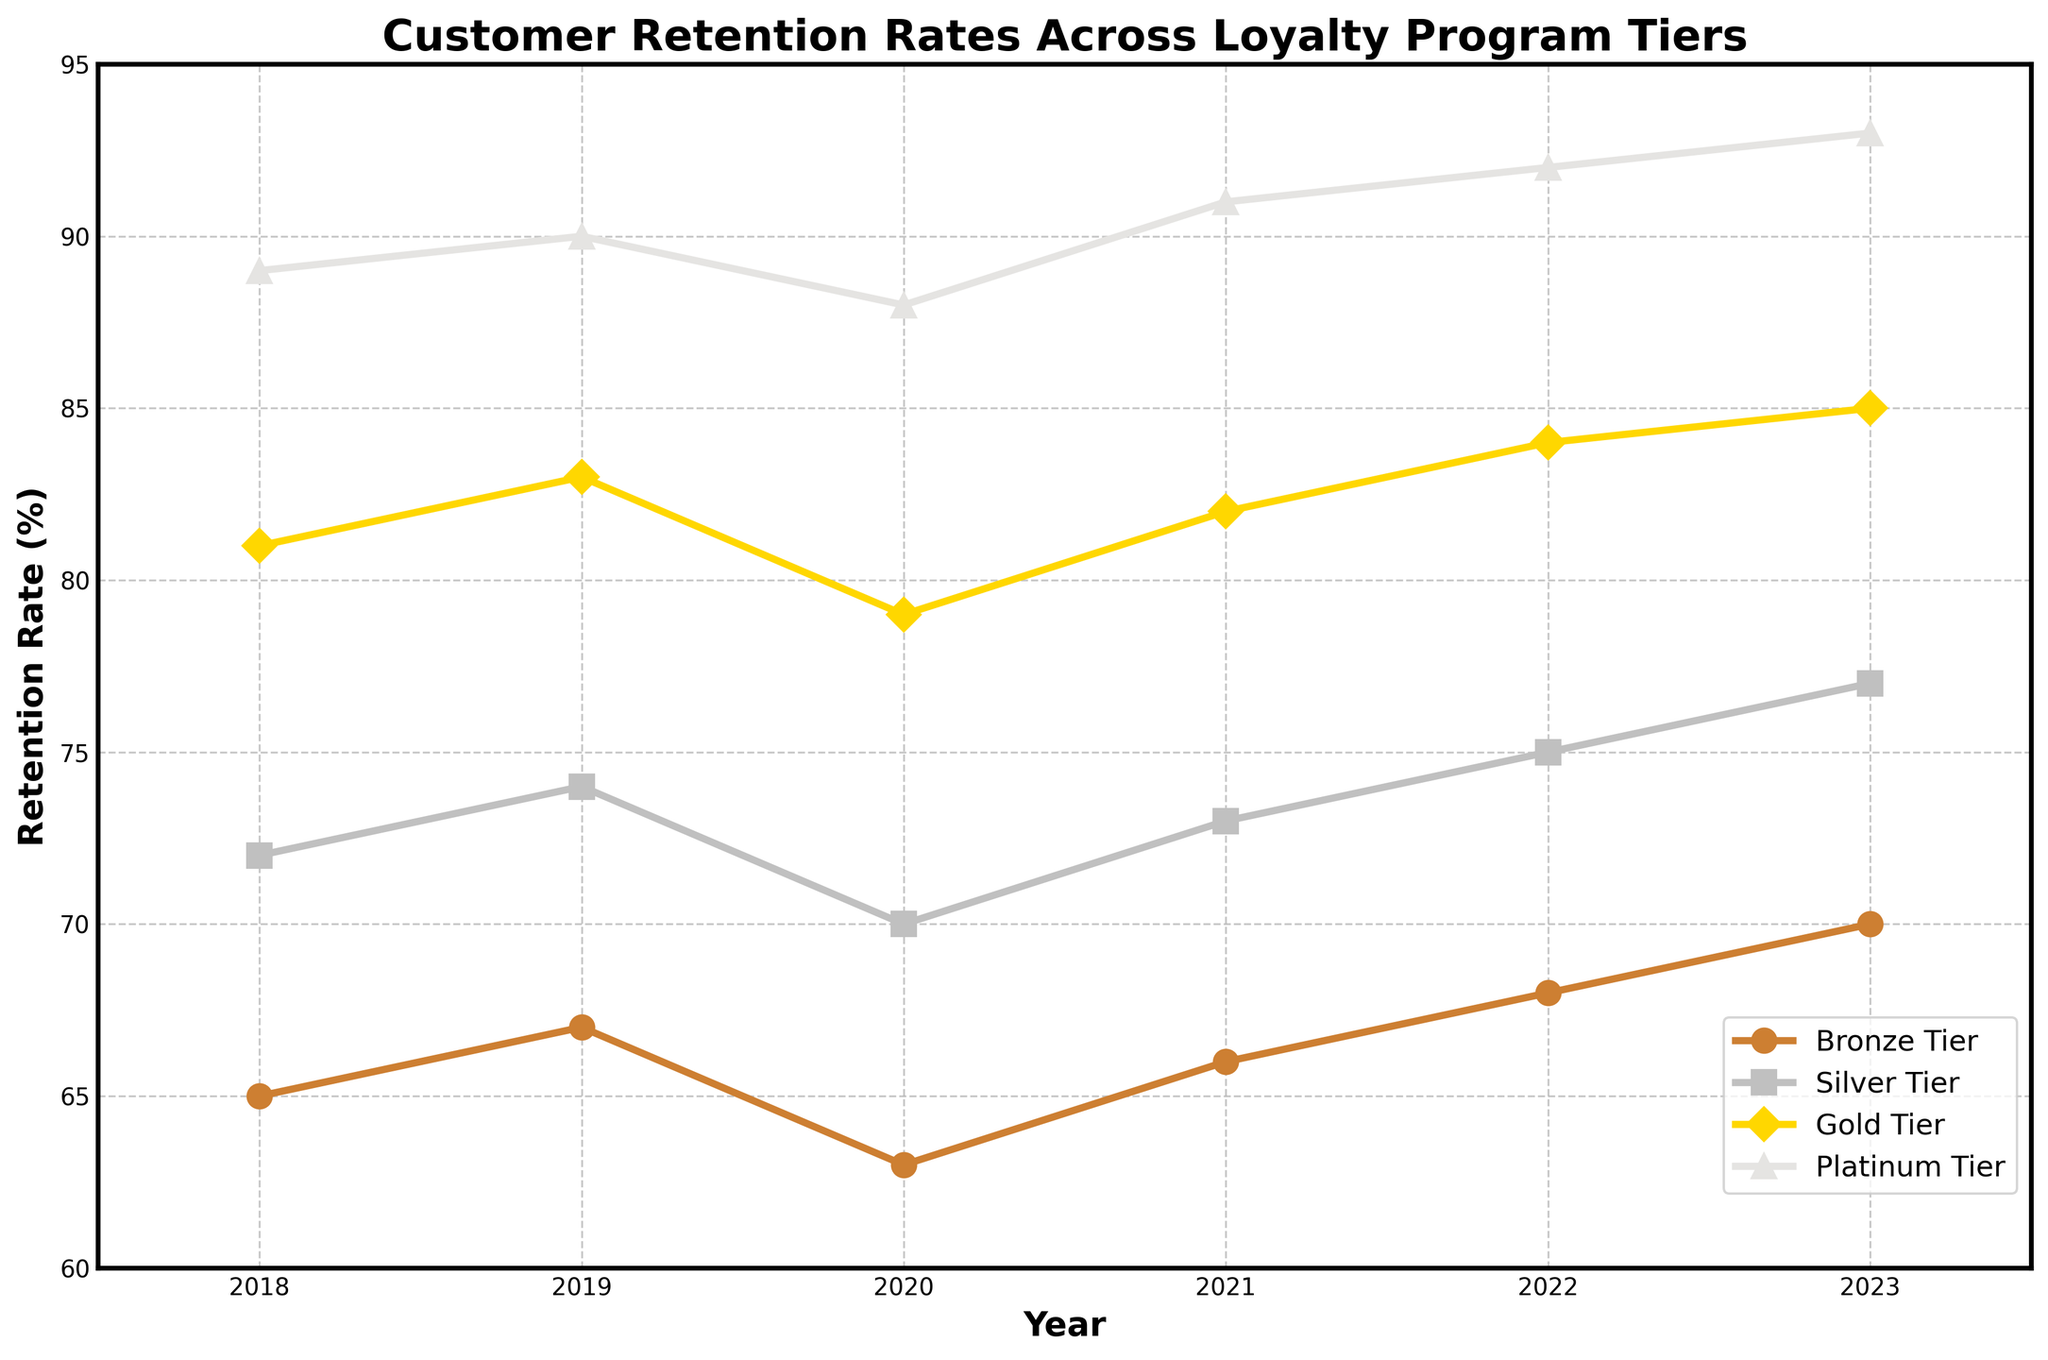Which year did the Bronze Tier have the lowest retention rate? Observing the line corresponding to the Bronze Tier, we notice that the lowest point is in the year 2020 at 63%.
Answer: 2020 Between 2018 and 2023, which tier had the highest overall retention rate? By looking at the highest points along each line from 2018 to 2023, the Platinum Tier in 2023 reached the highest level at 93%.
Answer: Platinum Tier By how much did the retention rate for the Gold Tier change from 2018 to 2023? We identify the retention rate for the Gold Tier in 2018 as 81% and in 2023 as 85%. The change is 85% - 81% = 4%.
Answer: 4% If we average the retention rates in 2021 across all tiers, what is the result? Adding the rates for each tier in 2021: 66% (Bronze) + 73% (Silver) + 82% (Gold) + 91% (Platinum) = 312%. Then, divide by 4: 312%/4 = 78%.
Answer: 78% Do the Silver and Gold tiers ever have the same retention rate within the displayed years? By examining each year along the chart, it is clear that the Silver and Gold tiers never intersect or share the same retention rate at any point.
Answer: No Which tier demonstrated the most consistent retention rate from 2018 to 2023? The most consistent retention rate would show the least variability. Observing the figures, the Silver Tier consistently stays around the 72-75% range, making it the most stable.
Answer: Silver Tier In which year did the Platinum Tier surpass a retention rate of 90%? Looking at the Platinum Tier line, it first surpasses 90% in the year 2019, reaching 91% by 2021 and continuing to grow.
Answer: 2019 Compare the increase in retention rate for the Silver Tier from 2018 to 2023 with that of the Bronze Tier. For the Silver Tier, the rate increased from 72% to 77%, a change of 5%. For the Bronze Tier, it increased from 65% to 70%, also a change of 5%. Both increased by the same amount.
Answer: 5% What is the average retention rate for the Platinum Tier across all displayed years? Sum the values across the years: 89% + 90% + 88% + 91% + 92% + 93% = 543%. Then, divide by 6: 543%/6 = 90.5%.
Answer: 90.5% During which years did the retention rate for the Bronze Tier both increase and then decrease? From the data, the retention rate for the Bronze Tier increased from 65% in 2018 to 67% in 2019, then decreased to 63% in 2020. Another increase is noticed from 66% in 2021 to 68% in 2022.
Answer: 2019-2020 and 2021-2022 